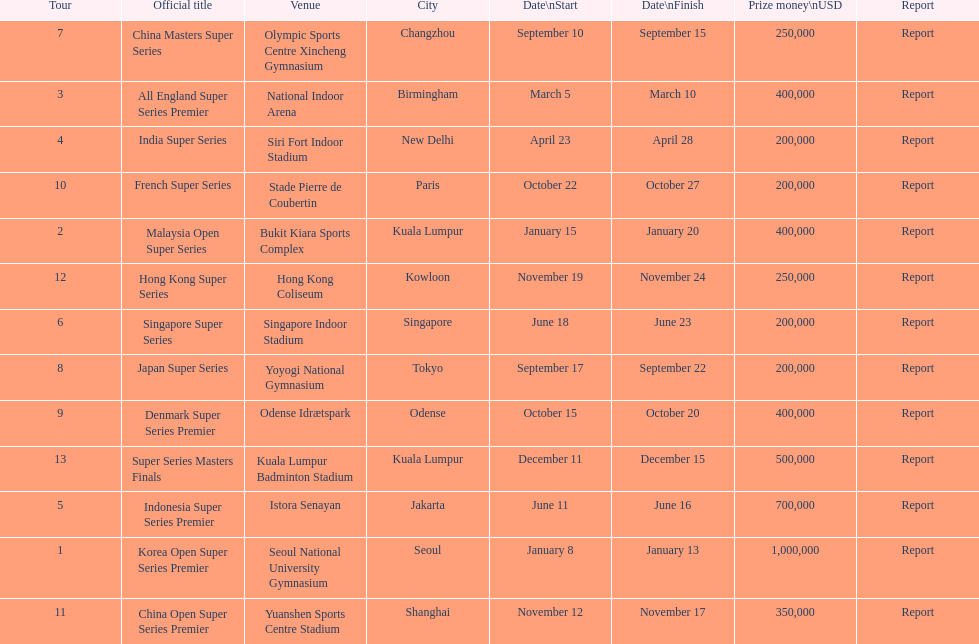Which has the same prize money as the french super series? Japan Super Series, Singapore Super Series, India Super Series. 